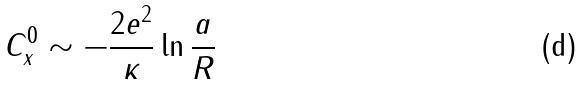<formula> <loc_0><loc_0><loc_500><loc_500>C _ { x } ^ { 0 } \sim - \frac { 2 e ^ { 2 } } { \kappa } \ln \frac { a } { R }</formula> 